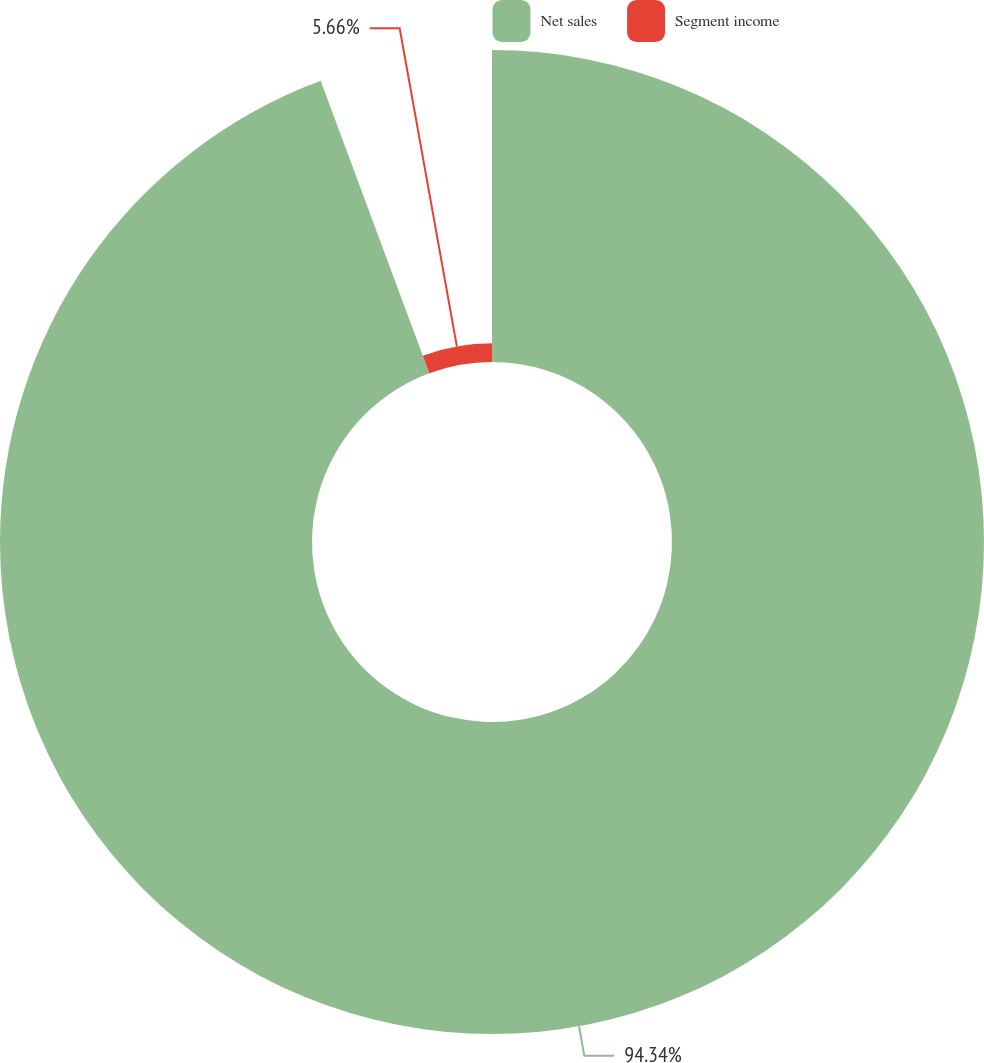Convert chart to OTSL. <chart><loc_0><loc_0><loc_500><loc_500><pie_chart><fcel>Net sales<fcel>Segment income<nl><fcel>94.34%<fcel>5.66%<nl></chart> 